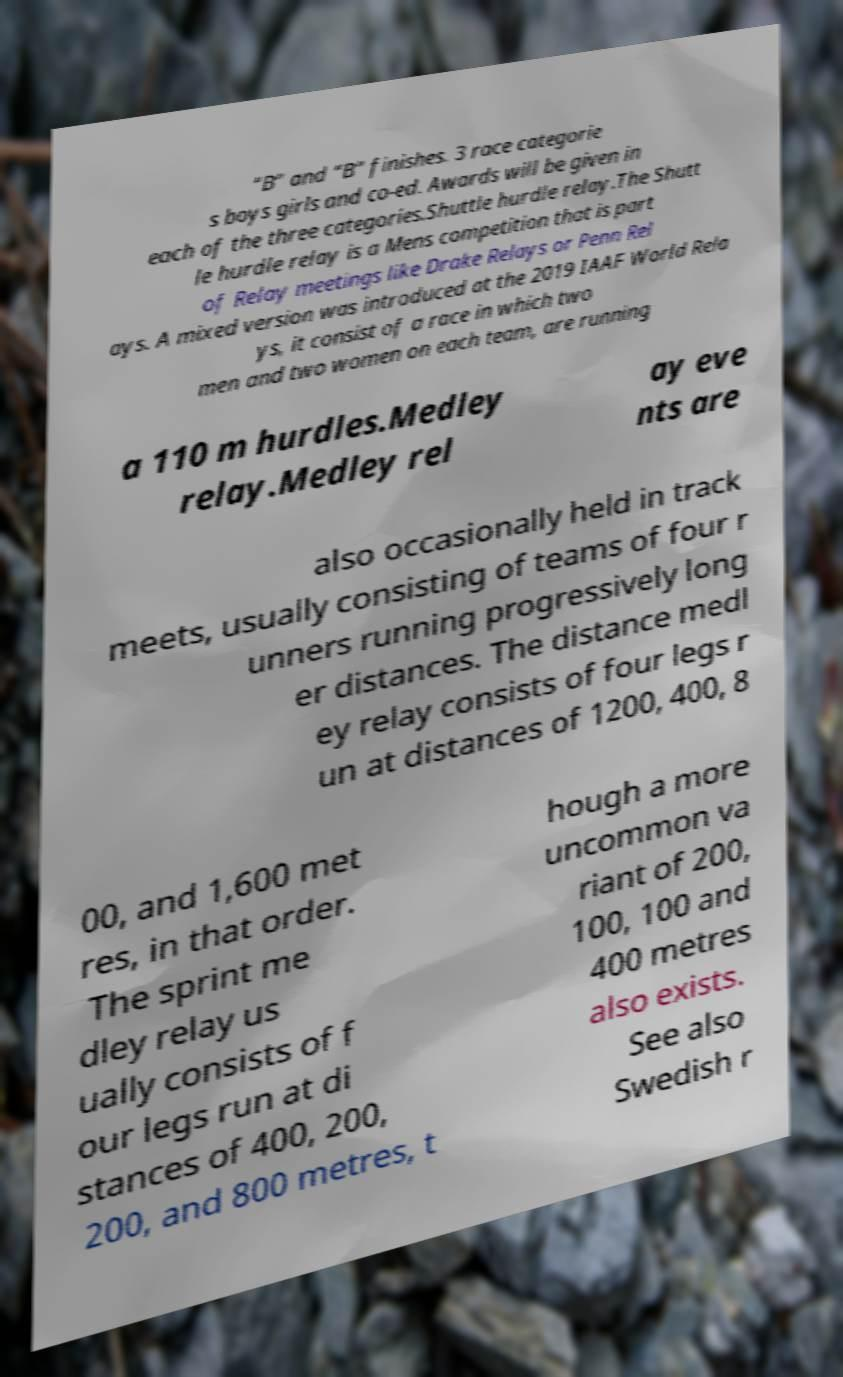Could you assist in decoding the text presented in this image and type it out clearly? “B” and “B” finishes. 3 race categorie s boys girls and co-ed. Awards will be given in each of the three categories.Shuttle hurdle relay.The Shutt le hurdle relay is a Mens competition that is part of Relay meetings like Drake Relays or Penn Rel ays. A mixed version was introduced at the 2019 IAAF World Rela ys, it consist of a race in which two men and two women on each team, are running a 110 m hurdles.Medley relay.Medley rel ay eve nts are also occasionally held in track meets, usually consisting of teams of four r unners running progressively long er distances. The distance medl ey relay consists of four legs r un at distances of 1200, 400, 8 00, and 1,600 met res, in that order. The sprint me dley relay us ually consists of f our legs run at di stances of 400, 200, 200, and 800 metres, t hough a more uncommon va riant of 200, 100, 100 and 400 metres also exists. See also Swedish r 